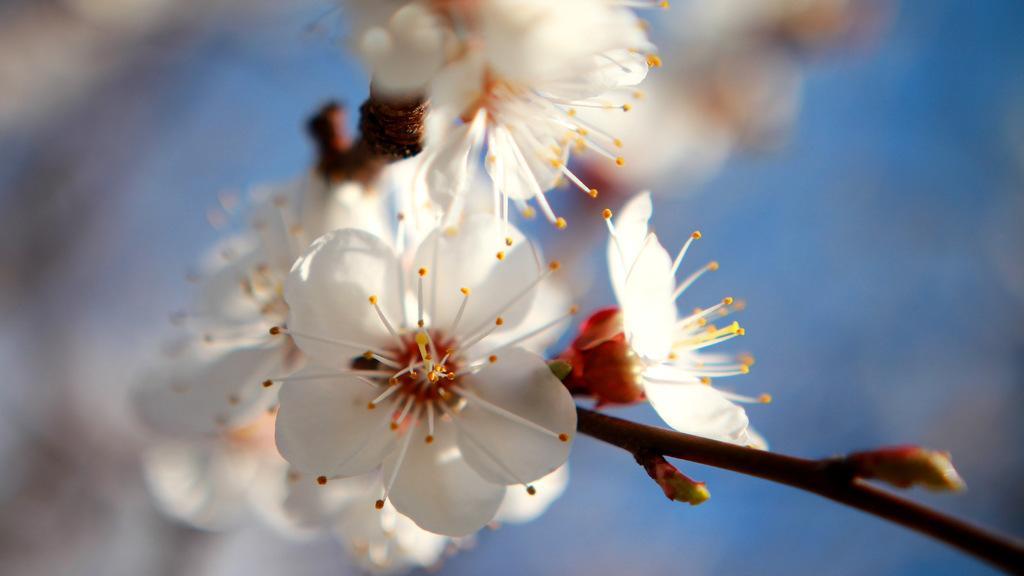Can you describe this image briefly? Here, we can see some white color flowers and there is a blur background. 